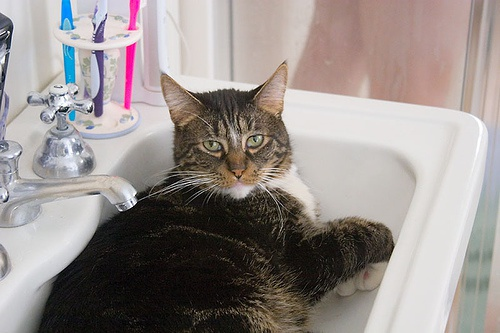Describe the objects in this image and their specific colors. I can see cat in lightgray, black, and gray tones, sink in lightgray, darkgray, and gray tones, people in lightgray, darkgray, and gray tones, toothbrush in lightgray, lavender, purple, and darkgray tones, and toothbrush in lightgray, lightblue, and teal tones in this image. 